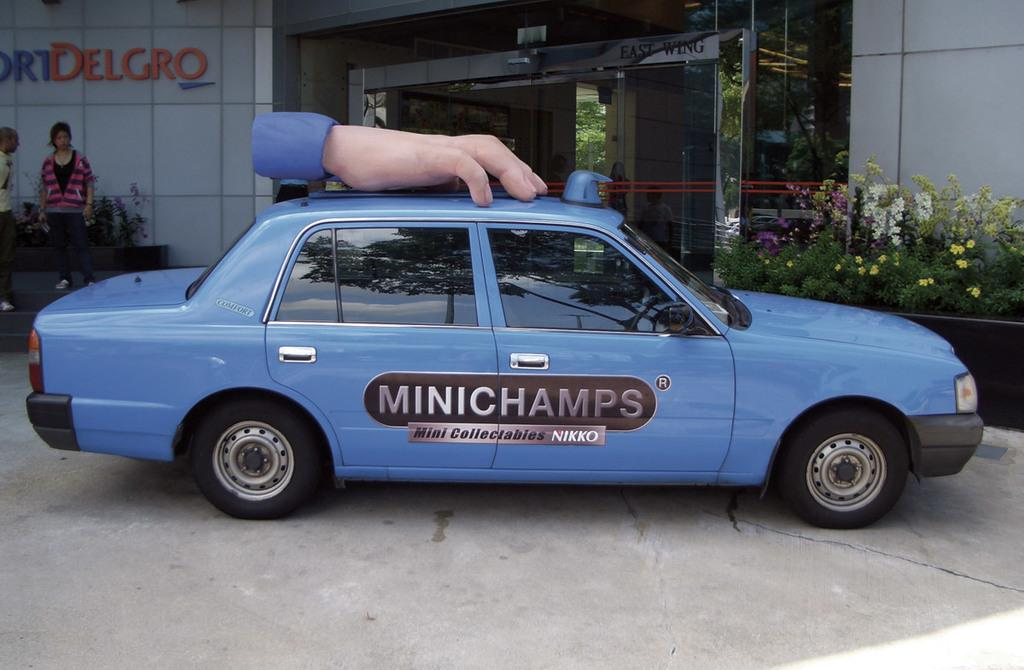<image>
Create a compact narrative representing the image presented. A blue car with a fake hand on top and the word "Minichamps" on the side sits in front of a building. 